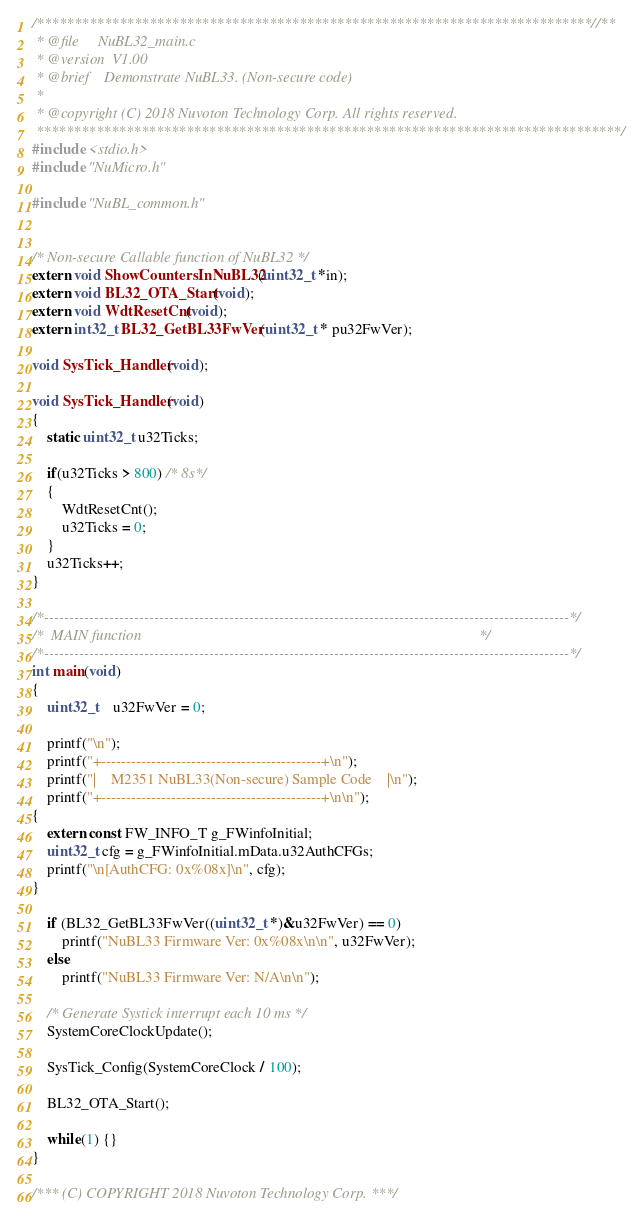Convert code to text. <code><loc_0><loc_0><loc_500><loc_500><_C_>/**************************************************************************//**
 * @file     NuBL32_main.c
 * @version  V1.00
 * @brief    Demonstrate NuBL33. (Non-secure code)
 *
 * @copyright (C) 2018 Nuvoton Technology Corp. All rights reserved.
 ******************************************************************************/
#include <stdio.h>
#include "NuMicro.h"

#include "NuBL_common.h"


/* Non-secure Callable function of NuBL32 */
extern void ShowCountersInNuBL32(uint32_t *in);
extern void BL32_OTA_Start(void);
extern void WdtResetCnt(void);
extern int32_t BL32_GetBL33FwVer(uint32_t * pu32FwVer);

void SysTick_Handler(void);

void SysTick_Handler(void)
{
    static uint32_t u32Ticks;

    if(u32Ticks > 800) /* 8s*/
    {
        WdtResetCnt();
        u32Ticks = 0;
    }
    u32Ticks++;
}

/*---------------------------------------------------------------------------------------------------------*/
/*  MAIN function                                                                                          */
/*---------------------------------------------------------------------------------------------------------*/
int main(void)
{
    uint32_t    u32FwVer = 0;

    printf("\n");
    printf("+--------------------------------------------+\n");
    printf("|    M2351 NuBL33(Non-secure) Sample Code    |\n");
    printf("+--------------------------------------------+\n\n");
{
    extern const FW_INFO_T g_FWinfoInitial;
    uint32_t cfg = g_FWinfoInitial.mData.u32AuthCFGs;
    printf("\n[AuthCFG: 0x%08x]\n", cfg);
}

    if (BL32_GetBL33FwVer((uint32_t *)&u32FwVer) == 0)
        printf("NuBL33 Firmware Ver: 0x%08x\n\n", u32FwVer);
    else
        printf("NuBL33 Firmware Ver: N/A\n\n");

    /* Generate Systick interrupt each 10 ms */
    SystemCoreClockUpdate();

    SysTick_Config(SystemCoreClock / 100);

    BL32_OTA_Start();

    while(1) {}
}

/*** (C) COPYRIGHT 2018 Nuvoton Technology Corp. ***/
</code> 